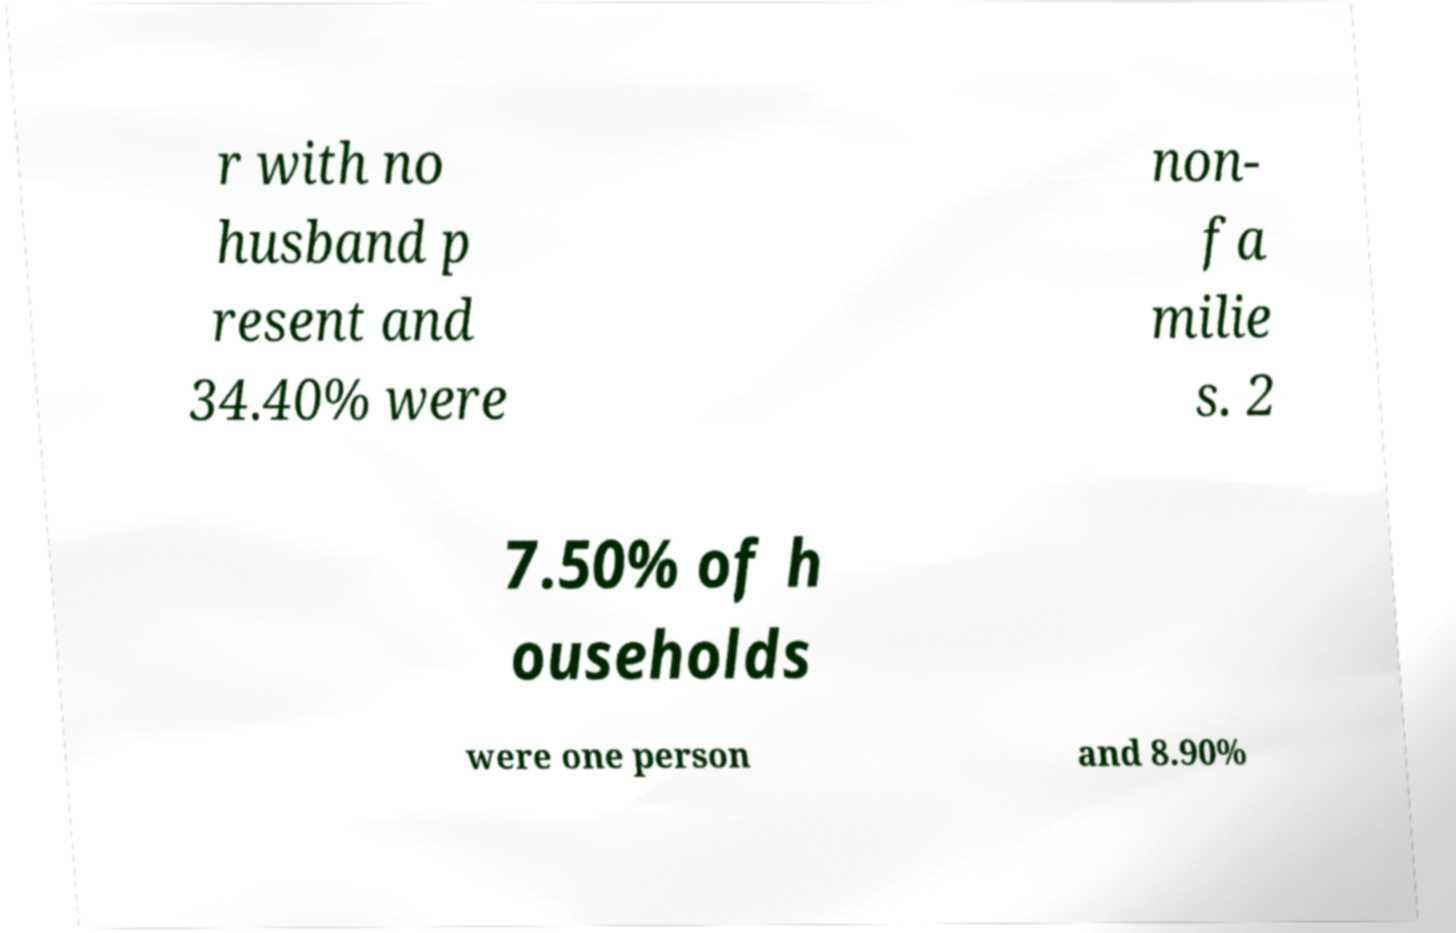There's text embedded in this image that I need extracted. Can you transcribe it verbatim? r with no husband p resent and 34.40% were non- fa milie s. 2 7.50% of h ouseholds were one person and 8.90% 